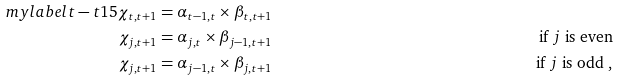Convert formula to latex. <formula><loc_0><loc_0><loc_500><loc_500>\ m y l a b e l { t - t 1 5 } \chi _ { t , t + 1 } & = \alpha _ { t - 1 , t } \times \beta _ { t , t + 1 } & \\ \chi _ { j , t + 1 } & = \alpha _ { j , t } \times \beta _ { j - 1 , t + 1 } & \text { if $j$ is even} \\ \chi _ { j , t + 1 } & = \alpha _ { j - 1 , t } \times \beta _ { j , t + 1 } & \text { if $j$ is odd } ,</formula> 